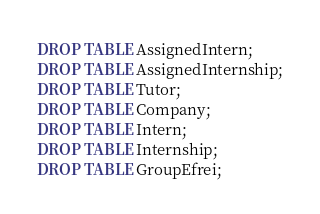Convert code to text. <code><loc_0><loc_0><loc_500><loc_500><_SQL_>DROP TABLE AssignedIntern;
DROP TABLE AssignedInternship;
DROP TABLE Tutor;
DROP TABLE Company;
DROP TABLE Intern;
DROP TABLE Internship;
DROP TABLE GroupEfrei;</code> 